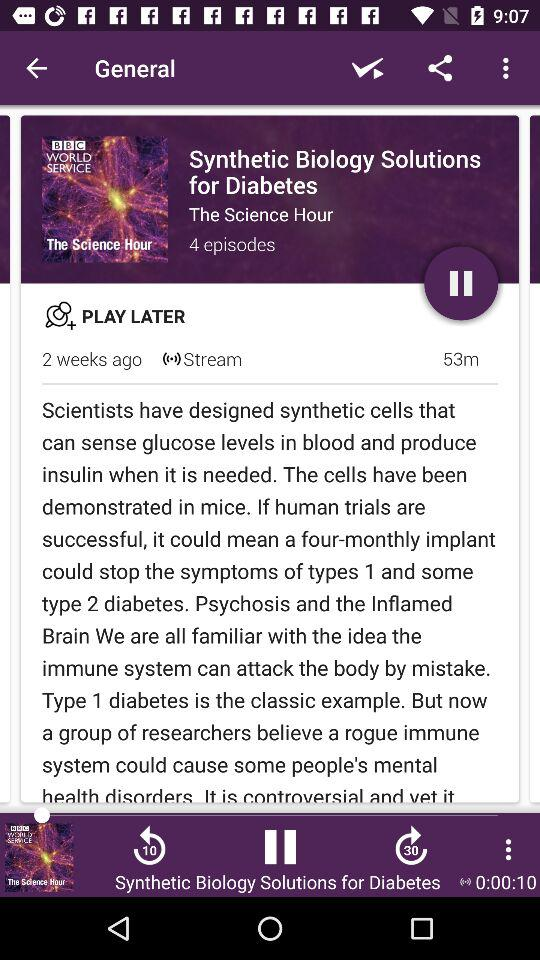How many episodes are there in the series? There are 4 episodes in the series. 